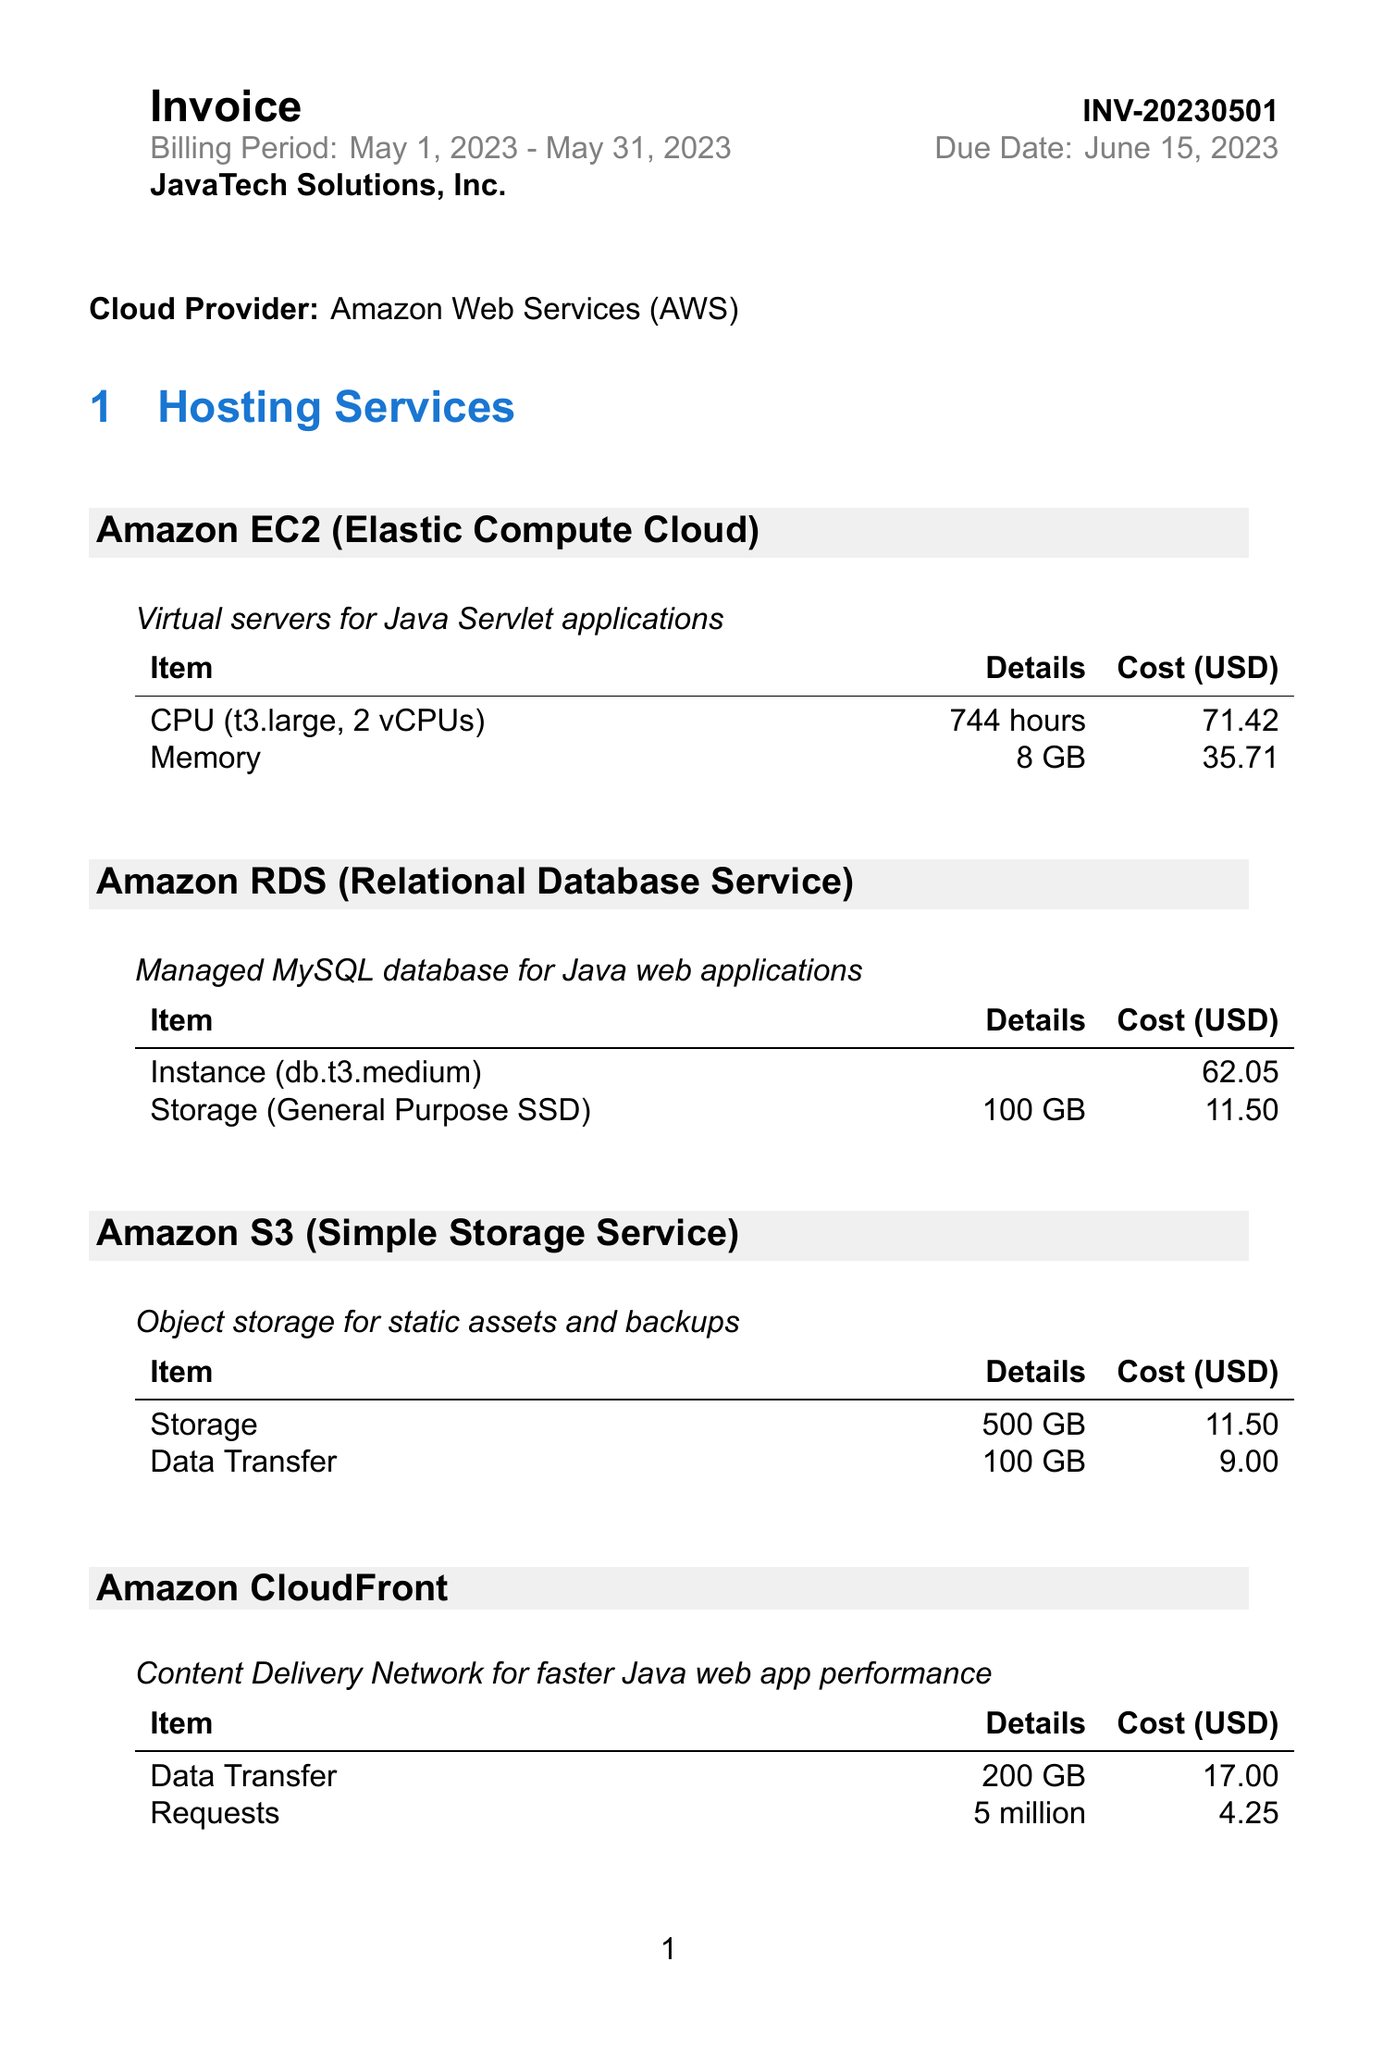What is the invoice number? The invoice number is specifically listed under the invoice details section.
Answer: INV-20230501 What is the total amount due? The total amount is provided at the end of the usage summary.
Answer: 237.43 What is the billing period? The billing period defines the duration for which the services are billed.
Answer: May 1, 2023 - May 31, 2023 How much does Amazon RDS cost? The cost for Amazon RDS is listed in the hosting services section.
Answer: 62.05 What is the total storage cost? The total storage cost is the sum of storage costs from different services in the usage summary.
Answer: 23.00 What is the due date for the invoice? The due date specifies when the payment is required and is given in the invoice details.
Answer: June 15, 2023 What type of primary service is Amazon EC2? Amazon EC2 is defined as a type of service provided in the hosting services section.
Answer: Virtual servers How many payment methods are listed? The number of payment methods provided indicates how many ways the client can settle the bill.
Answer: 3 What is the currency used for the invoice? The currency is indicated in the document and shows what type of currency the amount is in.
Answer: USD 